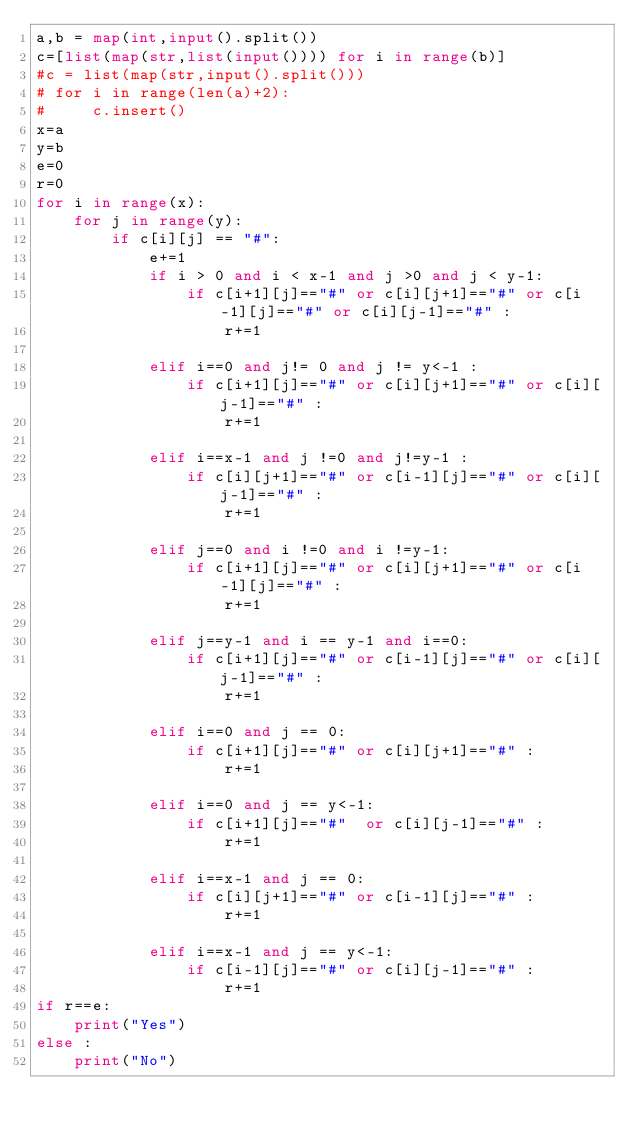Convert code to text. <code><loc_0><loc_0><loc_500><loc_500><_Python_>a,b = map(int,input().split())
c=[list(map(str,list(input()))) for i in range(b)]
#c = list(map(str,input().split()))
# for i in range(len(a)+2):
#     c.insert()
x=a
y=b
e=0
r=0
for i in range(x):
    for j in range(y):
        if c[i][j] == "#":
            e+=1
            if i > 0 and i < x-1 and j >0 and j < y-1:
                if c[i+1][j]=="#" or c[i][j+1]=="#" or c[i-1][j]=="#" or c[i][j-1]=="#" :
                    r+=1

            elif i==0 and j!= 0 and j != y<-1 :
                if c[i+1][j]=="#" or c[i][j+1]=="#" or c[i][j-1]=="#" :
                    r+=1

            elif i==x-1 and j !=0 and j!=y-1 :
                if c[i][j+1]=="#" or c[i-1][j]=="#" or c[i][j-1]=="#" :
                    r+=1

            elif j==0 and i !=0 and i !=y-1:
                if c[i+1][j]=="#" or c[i][j+1]=="#" or c[i-1][j]=="#" :
                    r+=1

            elif j==y-1 and i == y-1 and i==0:
                if c[i+1][j]=="#" or c[i-1][j]=="#" or c[i][j-1]=="#" :
                    r+=1

            elif i==0 and j == 0:
                if c[i+1][j]=="#" or c[i][j+1]=="#" :
                    r+=1

            elif i==0 and j == y<-1:
                if c[i+1][j]=="#"  or c[i][j-1]=="#" :
                    r+=1

            elif i==x-1 and j == 0:
                if c[i][j+1]=="#" or c[i-1][j]=="#" :
                    r+=1

            elif i==x-1 and j == y<-1:
                if c[i-1][j]=="#" or c[i][j-1]=="#" :
                    r+=1
if r==e:
    print("Yes")
else :
    print("No")
</code> 